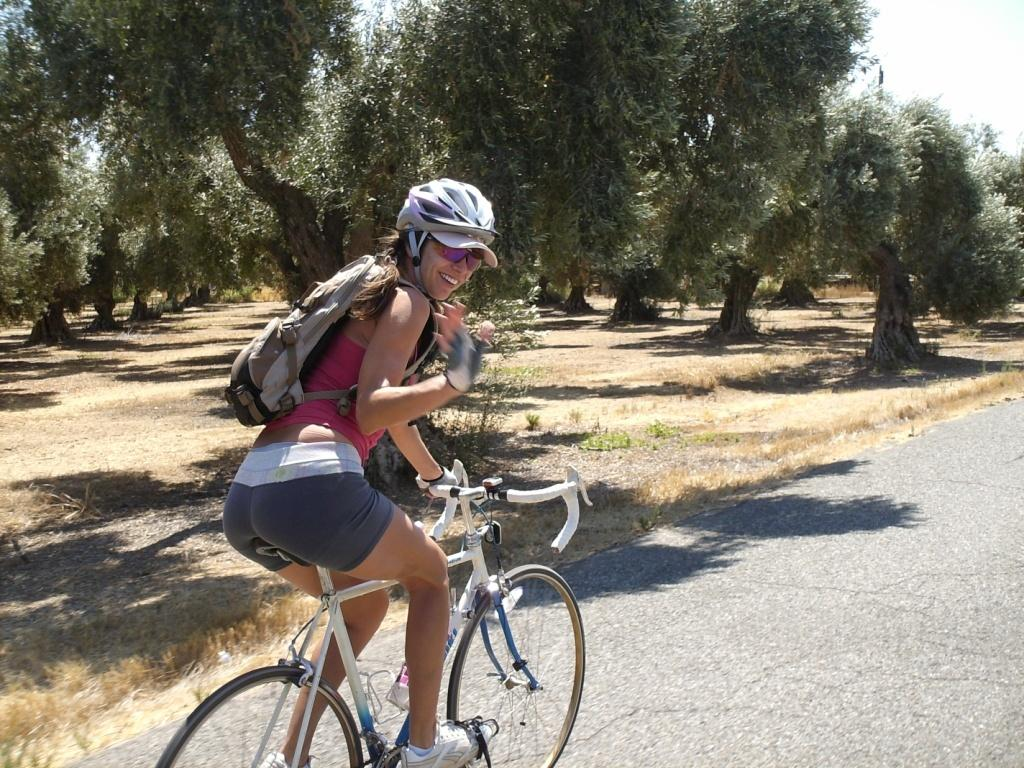Who is the main subject in the image? There is a woman in the image. What is the woman doing in the image? The woman is sitting on a bicycle. What is the woman holding in the image? The woman has a wire bag. What safety precaution is the woman taking in the image? The woman is wearing a helmet. What can be seen in the background of the image? There are trees in the background of the image. What type of pan is the woman using to cook in the image? There is no pan present in the image; the woman is sitting on a bicycle. What tax-related information can be seen on the woman's documents in the image? There are no documents or tax-related information visible in the image. 